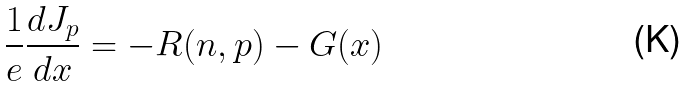Convert formula to latex. <formula><loc_0><loc_0><loc_500><loc_500>\frac { 1 } { e } \frac { d J _ { p } } { d x } = - R ( n , p ) - G ( x )</formula> 